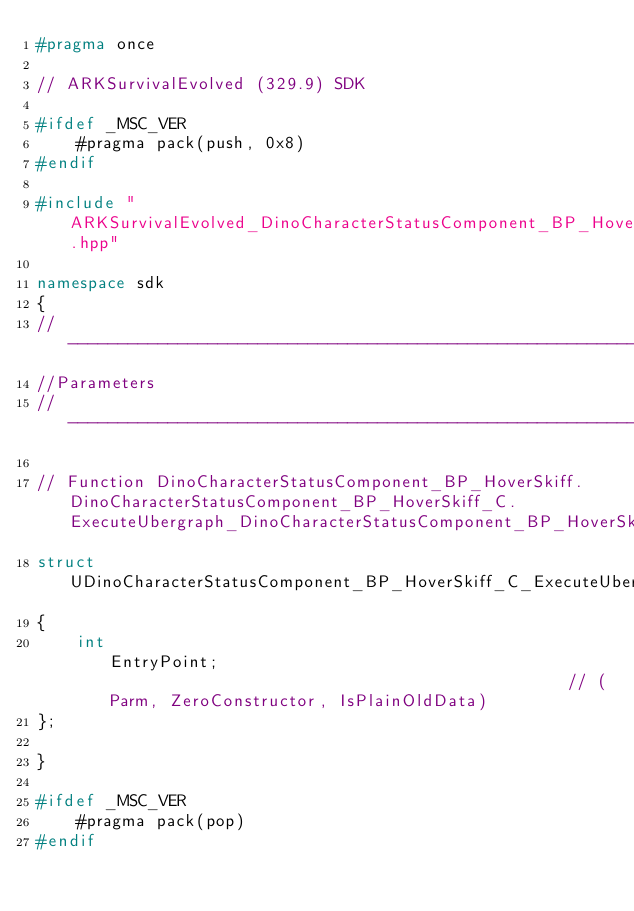<code> <loc_0><loc_0><loc_500><loc_500><_C++_>#pragma once

// ARKSurvivalEvolved (329.9) SDK

#ifdef _MSC_VER
	#pragma pack(push, 0x8)
#endif

#include "ARKSurvivalEvolved_DinoCharacterStatusComponent_BP_HoverSkiff_classes.hpp"

namespace sdk
{
//---------------------------------------------------------------------------
//Parameters
//---------------------------------------------------------------------------

// Function DinoCharacterStatusComponent_BP_HoverSkiff.DinoCharacterStatusComponent_BP_HoverSkiff_C.ExecuteUbergraph_DinoCharacterStatusComponent_BP_HoverSkiff
struct UDinoCharacterStatusComponent_BP_HoverSkiff_C_ExecuteUbergraph_DinoCharacterStatusComponent_BP_HoverSkiff_Params
{
	int                                                EntryPoint;                                               // (Parm, ZeroConstructor, IsPlainOldData)
};

}

#ifdef _MSC_VER
	#pragma pack(pop)
#endif
</code> 